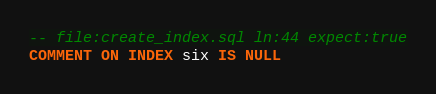Convert code to text. <code><loc_0><loc_0><loc_500><loc_500><_SQL_>-- file:create_index.sql ln:44 expect:true
COMMENT ON INDEX six IS NULL
</code> 